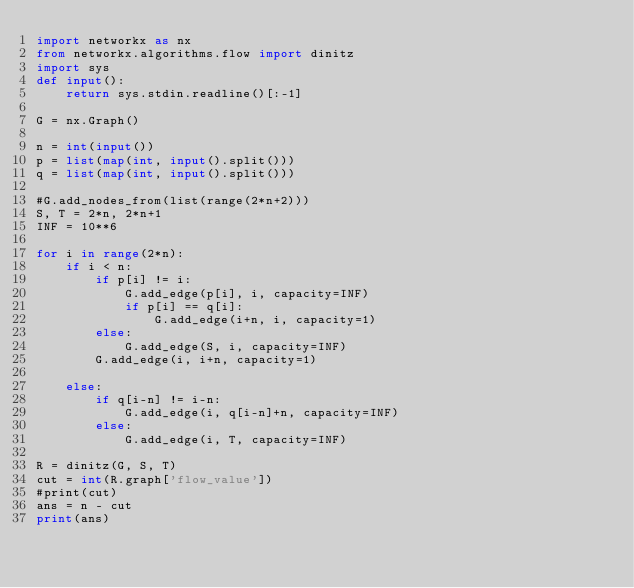Convert code to text. <code><loc_0><loc_0><loc_500><loc_500><_Python_>import networkx as nx
from networkx.algorithms.flow import dinitz
import sys
def input():
	return sys.stdin.readline()[:-1]

G = nx.Graph()

n = int(input())
p = list(map(int, input().split()))
q = list(map(int, input().split()))

#G.add_nodes_from(list(range(2*n+2)))
S, T = 2*n, 2*n+1
INF = 10**6

for i in range(2*n):
	if i < n:
		if p[i] != i:
			G.add_edge(p[i], i, capacity=INF)
			if p[i] == q[i]:
				G.add_edge(i+n, i, capacity=1)
		else:
			G.add_edge(S, i, capacity=INF)
		G.add_edge(i, i+n, capacity=1)
			
	else:
		if q[i-n] != i-n:
			G.add_edge(i, q[i-n]+n, capacity=INF)
		else:
			G.add_edge(i, T, capacity=INF)

R = dinitz(G, S, T)
cut = int(R.graph['flow_value'])
#print(cut)
ans = n - cut
print(ans)</code> 